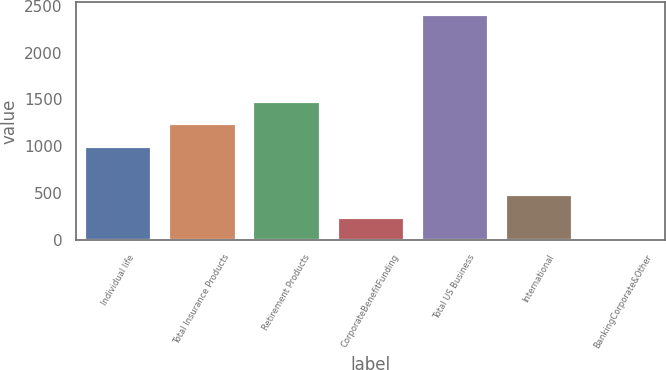<chart> <loc_0><loc_0><loc_500><loc_500><bar_chart><fcel>Individual life<fcel>Total Insurance Products<fcel>Retirement Products<fcel>CorporateBenefitFunding<fcel>Total US Business<fcel>International<fcel>BankingCorporate&Other<nl><fcel>1005<fcel>1246.8<fcel>1488.6<fcel>242.8<fcel>2419<fcel>484.6<fcel>1<nl></chart> 